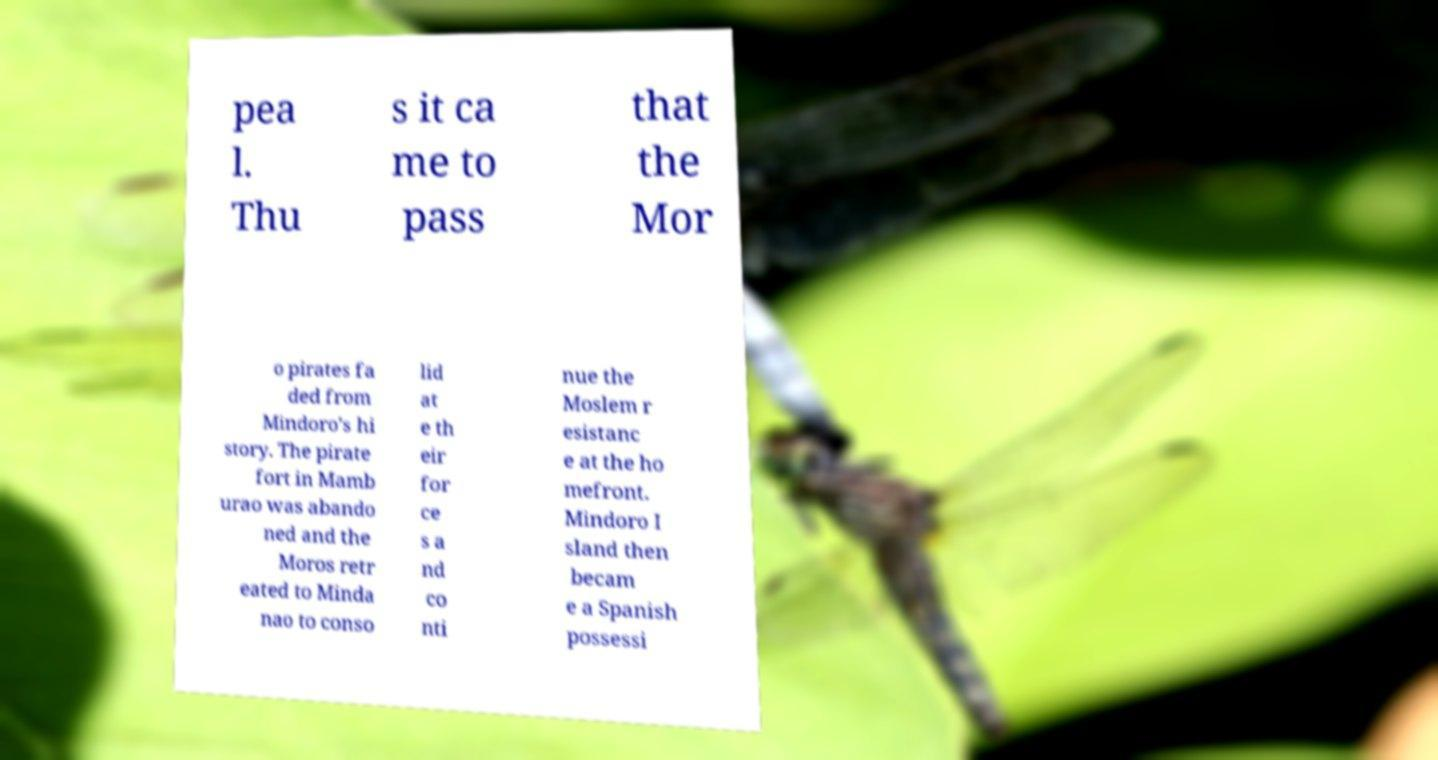Can you read and provide the text displayed in the image?This photo seems to have some interesting text. Can you extract and type it out for me? pea l. Thu s it ca me to pass that the Mor o pirates fa ded from Mindoro's hi story. The pirate fort in Mamb urao was abando ned and the Moros retr eated to Minda nao to conso lid at e th eir for ce s a nd co nti nue the Moslem r esistanc e at the ho mefront. Mindoro I sland then becam e a Spanish possessi 